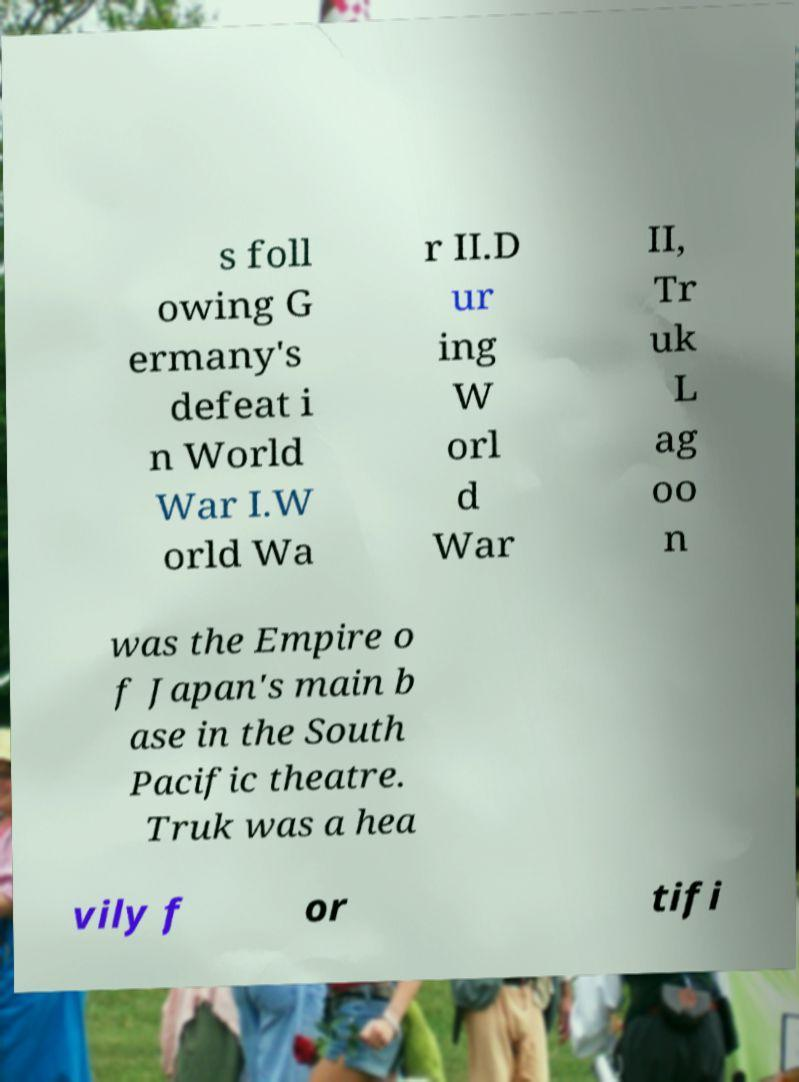Please identify and transcribe the text found in this image. s foll owing G ermany's defeat i n World War I.W orld Wa r II.D ur ing W orl d War II, Tr uk L ag oo n was the Empire o f Japan's main b ase in the South Pacific theatre. Truk was a hea vily f or tifi 